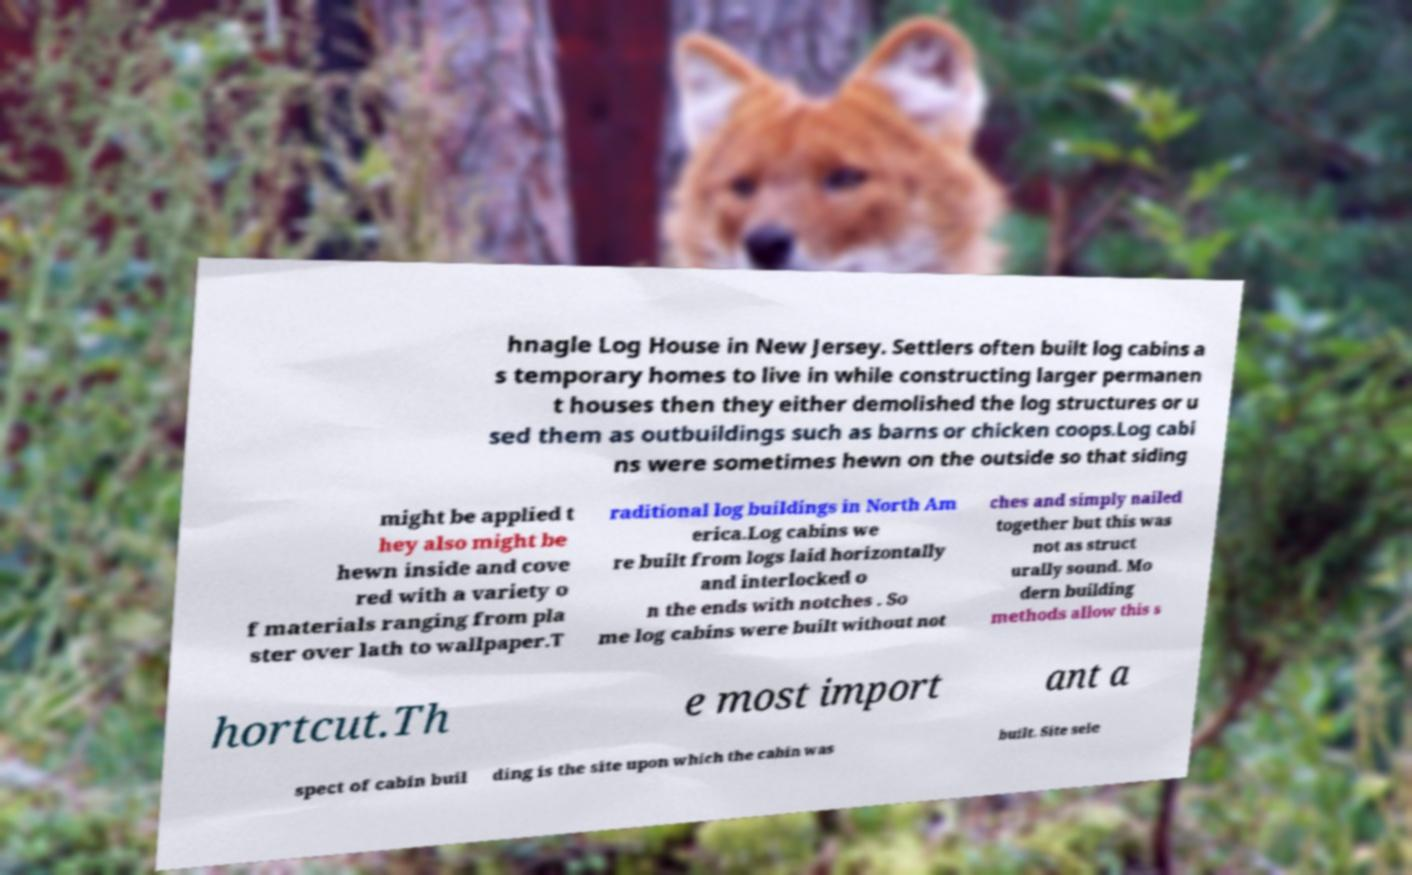Could you extract and type out the text from this image? hnagle Log House in New Jersey. Settlers often built log cabins a s temporary homes to live in while constructing larger permanen t houses then they either demolished the log structures or u sed them as outbuildings such as barns or chicken coops.Log cabi ns were sometimes hewn on the outside so that siding might be applied t hey also might be hewn inside and cove red with a variety o f materials ranging from pla ster over lath to wallpaper.T raditional log buildings in North Am erica.Log cabins we re built from logs laid horizontally and interlocked o n the ends with notches . So me log cabins were built without not ches and simply nailed together but this was not as struct urally sound. Mo dern building methods allow this s hortcut.Th e most import ant a spect of cabin buil ding is the site upon which the cabin was built. Site sele 